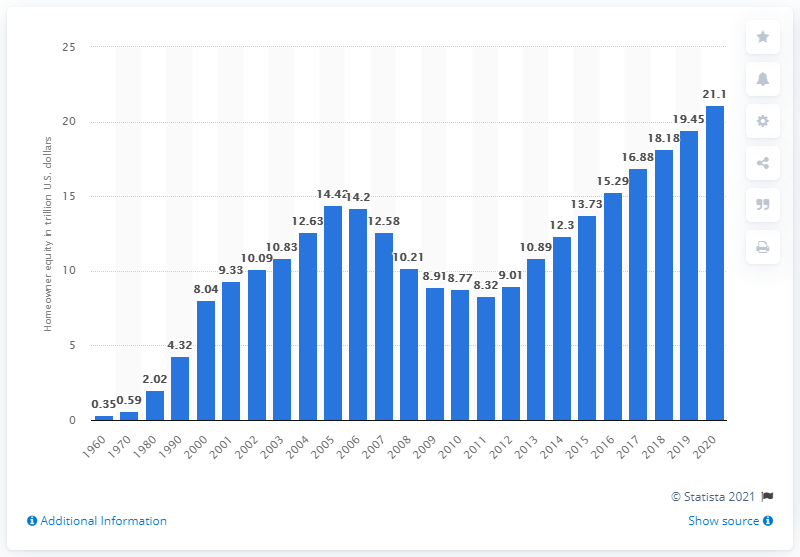Point out several critical features in this image. In 2010, the value of homeowner equity in the United States was approximately $8.77 trillion. 